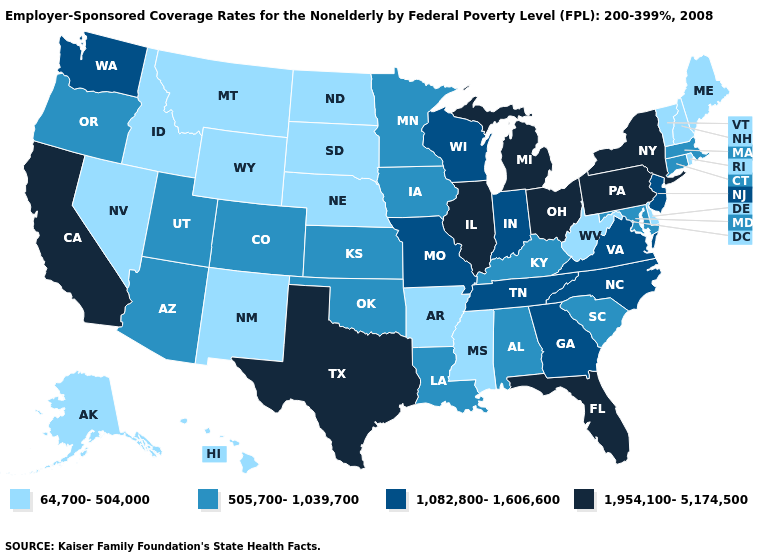Among the states that border Idaho , which have the highest value?
Give a very brief answer. Washington. Does Massachusetts have the highest value in the Northeast?
Write a very short answer. No. What is the lowest value in the West?
Write a very short answer. 64,700-504,000. What is the value of Arkansas?
Short answer required. 64,700-504,000. What is the value of Rhode Island?
Answer briefly. 64,700-504,000. What is the value of Arizona?
Short answer required. 505,700-1,039,700. Name the states that have a value in the range 1,082,800-1,606,600?
Write a very short answer. Georgia, Indiana, Missouri, New Jersey, North Carolina, Tennessee, Virginia, Washington, Wisconsin. Among the states that border Massachusetts , does New York have the highest value?
Concise answer only. Yes. Does the first symbol in the legend represent the smallest category?
Write a very short answer. Yes. Is the legend a continuous bar?
Quick response, please. No. Among the states that border Wyoming , which have the lowest value?
Answer briefly. Idaho, Montana, Nebraska, South Dakota. Name the states that have a value in the range 1,082,800-1,606,600?
Give a very brief answer. Georgia, Indiana, Missouri, New Jersey, North Carolina, Tennessee, Virginia, Washington, Wisconsin. Among the states that border Louisiana , does Mississippi have the highest value?
Give a very brief answer. No. Does Pennsylvania have a higher value than New York?
Concise answer only. No. What is the value of Illinois?
Short answer required. 1,954,100-5,174,500. 